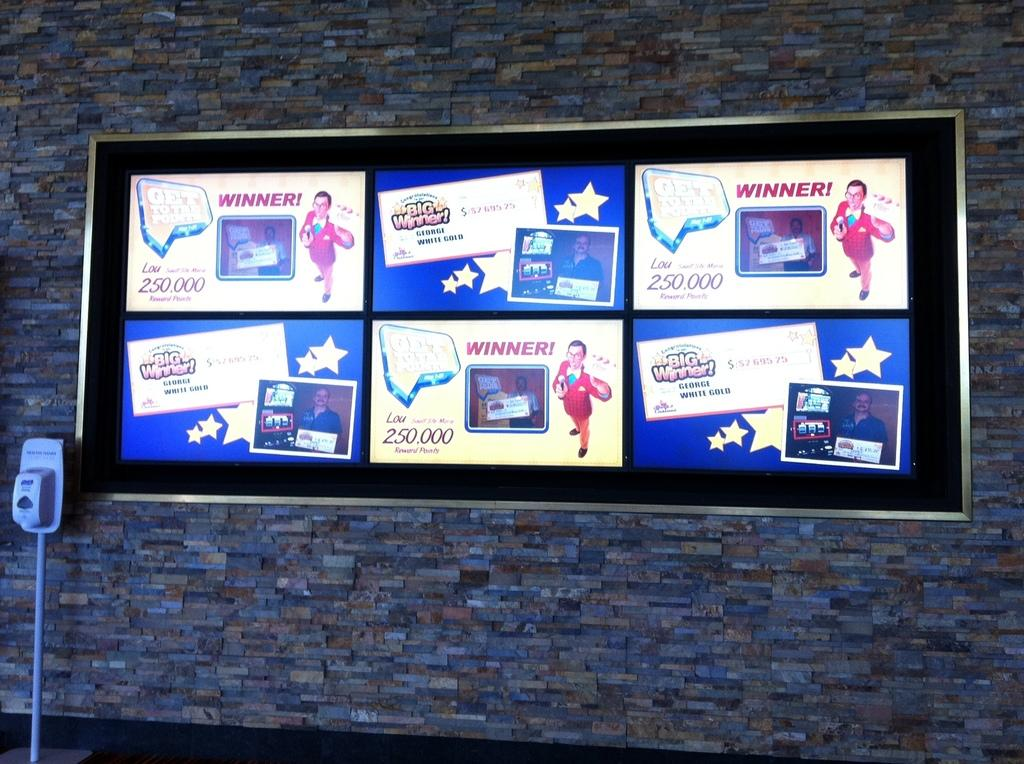What type of posters are displayed on the notice board in the image? There are lottery winners posters in the image. Where is the notice board located? The notice board is on a wall. What is the notice board used for? The notice board is used to display posters, such as the lottery winners posters. What shape is the faucet in the image? There is no faucet present in the image. 